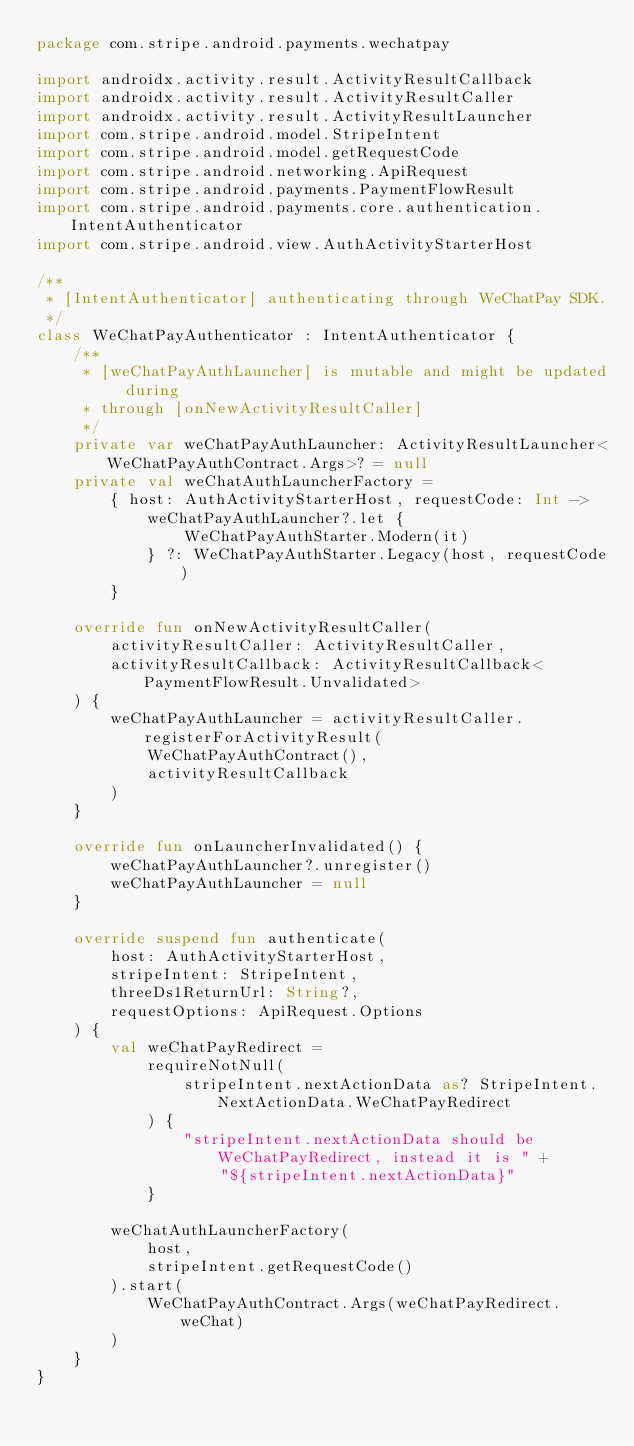Convert code to text. <code><loc_0><loc_0><loc_500><loc_500><_Kotlin_>package com.stripe.android.payments.wechatpay

import androidx.activity.result.ActivityResultCallback
import androidx.activity.result.ActivityResultCaller
import androidx.activity.result.ActivityResultLauncher
import com.stripe.android.model.StripeIntent
import com.stripe.android.model.getRequestCode
import com.stripe.android.networking.ApiRequest
import com.stripe.android.payments.PaymentFlowResult
import com.stripe.android.payments.core.authentication.IntentAuthenticator
import com.stripe.android.view.AuthActivityStarterHost

/**
 * [IntentAuthenticator] authenticating through WeChatPay SDK.
 */
class WeChatPayAuthenticator : IntentAuthenticator {
    /**
     * [weChatPayAuthLauncher] is mutable and might be updated during
     * through [onNewActivityResultCaller]
     */
    private var weChatPayAuthLauncher: ActivityResultLauncher<WeChatPayAuthContract.Args>? = null
    private val weChatAuthLauncherFactory =
        { host: AuthActivityStarterHost, requestCode: Int ->
            weChatPayAuthLauncher?.let {
                WeChatPayAuthStarter.Modern(it)
            } ?: WeChatPayAuthStarter.Legacy(host, requestCode)
        }

    override fun onNewActivityResultCaller(
        activityResultCaller: ActivityResultCaller,
        activityResultCallback: ActivityResultCallback<PaymentFlowResult.Unvalidated>
    ) {
        weChatPayAuthLauncher = activityResultCaller.registerForActivityResult(
            WeChatPayAuthContract(),
            activityResultCallback
        )
    }

    override fun onLauncherInvalidated() {
        weChatPayAuthLauncher?.unregister()
        weChatPayAuthLauncher = null
    }

    override suspend fun authenticate(
        host: AuthActivityStarterHost,
        stripeIntent: StripeIntent,
        threeDs1ReturnUrl: String?,
        requestOptions: ApiRequest.Options
    ) {
        val weChatPayRedirect =
            requireNotNull(
                stripeIntent.nextActionData as? StripeIntent.NextActionData.WeChatPayRedirect
            ) {
                "stripeIntent.nextActionData should be WeChatPayRedirect, instead it is " +
                    "${stripeIntent.nextActionData}"
            }

        weChatAuthLauncherFactory(
            host,
            stripeIntent.getRequestCode()
        ).start(
            WeChatPayAuthContract.Args(weChatPayRedirect.weChat)
        )
    }
}
</code> 